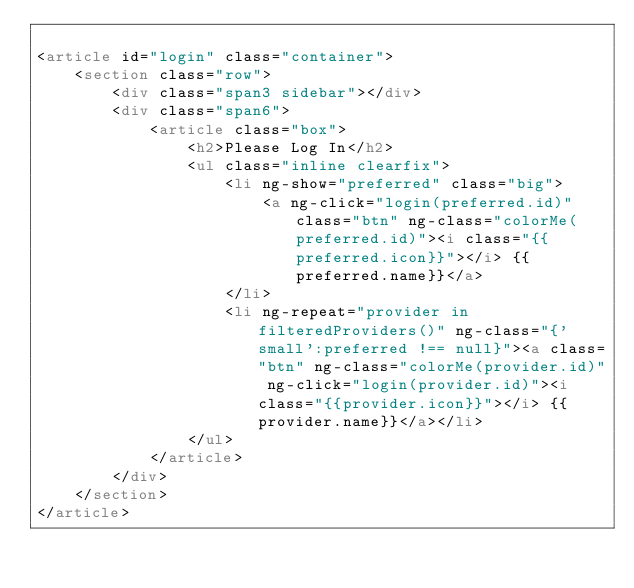<code> <loc_0><loc_0><loc_500><loc_500><_HTML_>
<article id="login" class="container">
    <section class="row">
        <div class="span3 sidebar"></div>
        <div class="span6">
            <article class="box">
                <h2>Please Log In</h2>
                <ul class="inline clearfix">
                    <li ng-show="preferred" class="big">
                        <a ng-click="login(preferred.id)" class="btn" ng-class="colorMe(preferred.id)"><i class="{{preferred.icon}}"></i> {{preferred.name}}</a>
                    </li>
                    <li ng-repeat="provider in filteredProviders()" ng-class="{'small':preferred !== null}"><a class="btn" ng-class="colorMe(provider.id)" ng-click="login(provider.id)"><i class="{{provider.icon}}"></i> {{provider.name}}</a></li>
                </ul>
            </article>
        </div>
    </section>
</article>
</code> 